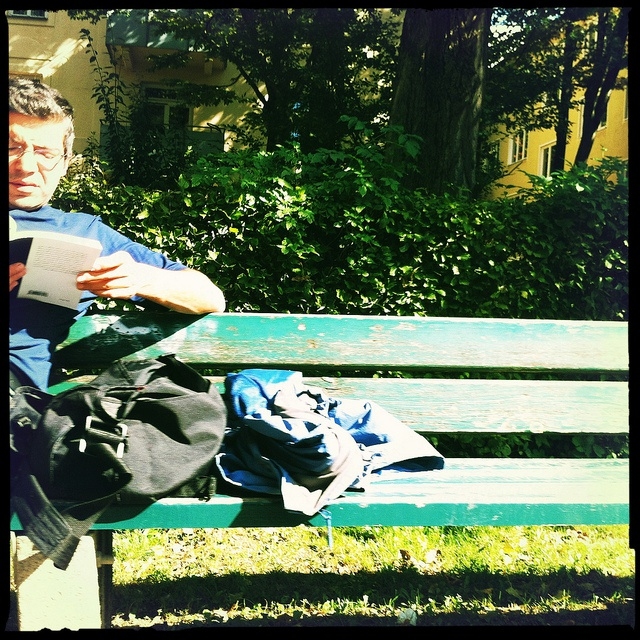Describe the objects in this image and their specific colors. I can see bench in black, beige, aquamarine, and turquoise tones, handbag in black, darkgray, gray, and beige tones, people in black, beige, lightblue, and tan tones, and backpack in black, darkgray, gray, and lightgray tones in this image. 